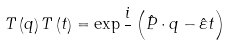<formula> <loc_0><loc_0><loc_500><loc_500>T \left ( q \right ) T \left ( t \right ) = \exp \frac { i } { } \left ( \hat { P } \cdot q - { \hat { \varepsilon } t } \right )</formula> 